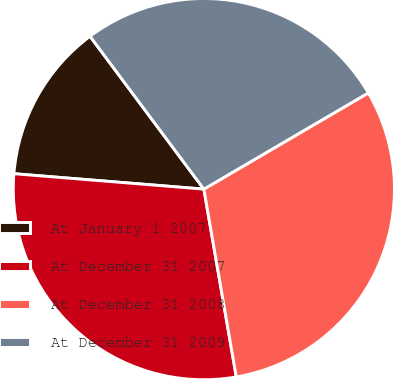Convert chart. <chart><loc_0><loc_0><loc_500><loc_500><pie_chart><fcel>At January 1 2007<fcel>At December 31 2007<fcel>At December 31 2008<fcel>At December 31 2009<nl><fcel>13.52%<fcel>29.01%<fcel>30.7%<fcel>26.76%<nl></chart> 